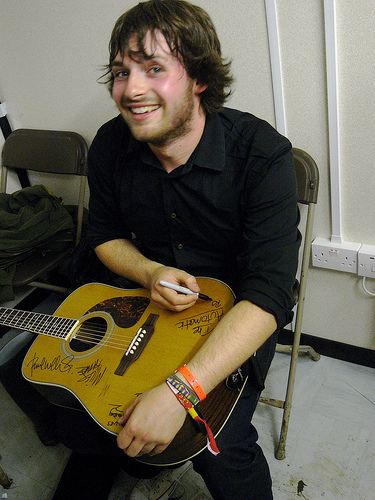<image>
Can you confirm if the guitar is on the floor? No. The guitar is not positioned on the floor. They may be near each other, but the guitar is not supported by or resting on top of the floor. Is the man to the left of the guitar? No. The man is not to the left of the guitar. From this viewpoint, they have a different horizontal relationship. 